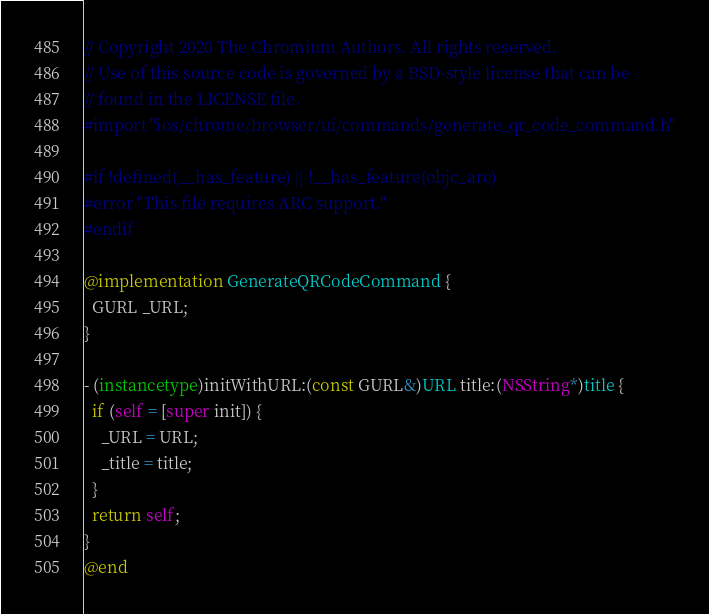<code> <loc_0><loc_0><loc_500><loc_500><_ObjectiveC_>// Copyright 2020 The Chromium Authors. All rights reserved.
// Use of this source code is governed by a BSD-style license that can be
// found in the LICENSE file.
#import "ios/chrome/browser/ui/commands/generate_qr_code_command.h"

#if !defined(__has_feature) || !__has_feature(objc_arc)
#error "This file requires ARC support."
#endif

@implementation GenerateQRCodeCommand {
  GURL _URL;
}

- (instancetype)initWithURL:(const GURL&)URL title:(NSString*)title {
  if (self = [super init]) {
    _URL = URL;
    _title = title;
  }
  return self;
}
@end
</code> 